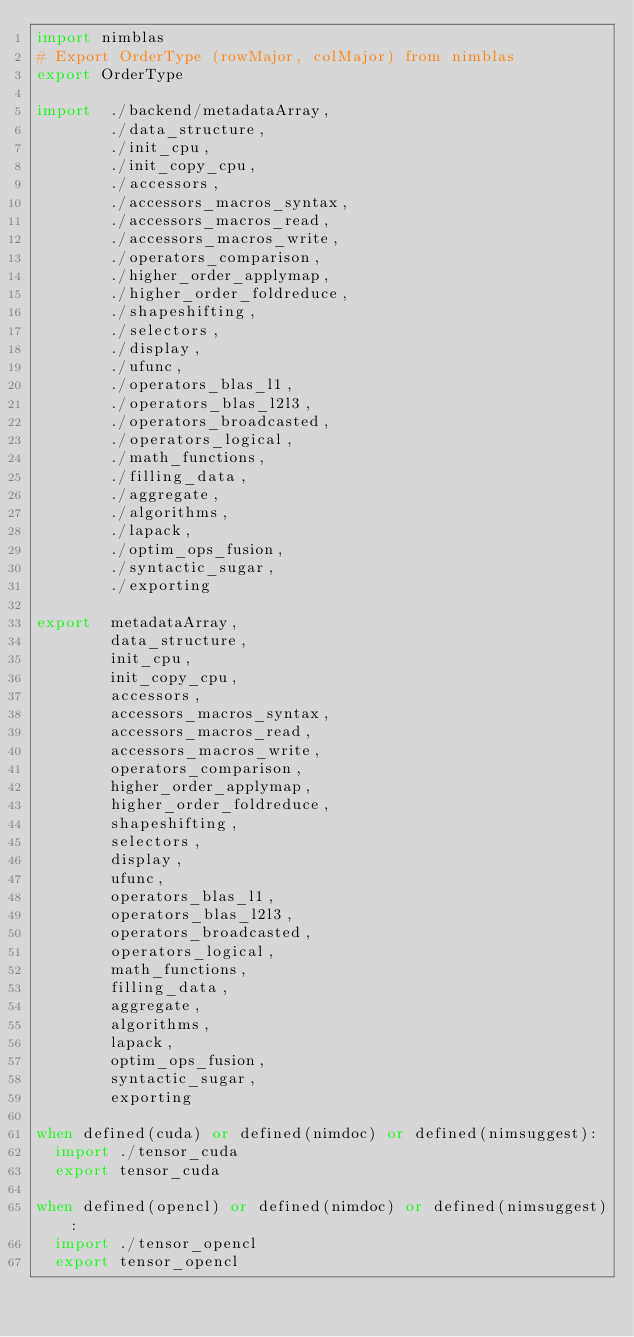<code> <loc_0><loc_0><loc_500><loc_500><_Nim_>import nimblas
# Export OrderType (rowMajor, colMajor) from nimblas
export OrderType

import  ./backend/metadataArray,
        ./data_structure,
        ./init_cpu,
        ./init_copy_cpu,
        ./accessors,
        ./accessors_macros_syntax,
        ./accessors_macros_read,
        ./accessors_macros_write,
        ./operators_comparison,
        ./higher_order_applymap,
        ./higher_order_foldreduce,
        ./shapeshifting,
        ./selectors,
        ./display,
        ./ufunc,
        ./operators_blas_l1,
        ./operators_blas_l2l3,
        ./operators_broadcasted,
        ./operators_logical,
        ./math_functions,
        ./filling_data,
        ./aggregate,
        ./algorithms,
        ./lapack,
        ./optim_ops_fusion,
        ./syntactic_sugar,
        ./exporting

export  metadataArray,
        data_structure,
        init_cpu,
        init_copy_cpu,
        accessors,
        accessors_macros_syntax,
        accessors_macros_read,
        accessors_macros_write,
        operators_comparison,
        higher_order_applymap,
        higher_order_foldreduce,
        shapeshifting,
        selectors,
        display,
        ufunc,
        operators_blas_l1,
        operators_blas_l2l3,
        operators_broadcasted,
        operators_logical,
        math_functions,
        filling_data,
        aggregate,
        algorithms,
        lapack,
        optim_ops_fusion,
        syntactic_sugar,
        exporting

when defined(cuda) or defined(nimdoc) or defined(nimsuggest):
  import ./tensor_cuda
  export tensor_cuda

when defined(opencl) or defined(nimdoc) or defined(nimsuggest):
  import ./tensor_opencl
  export tensor_opencl
</code> 